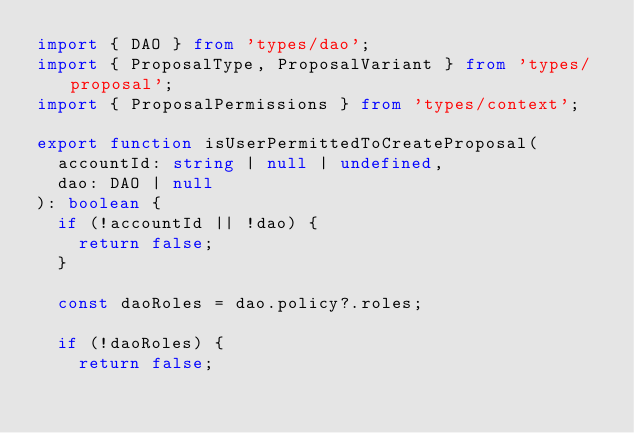Convert code to text. <code><loc_0><loc_0><loc_500><loc_500><_TypeScript_>import { DAO } from 'types/dao';
import { ProposalType, ProposalVariant } from 'types/proposal';
import { ProposalPermissions } from 'types/context';

export function isUserPermittedToCreateProposal(
  accountId: string | null | undefined,
  dao: DAO | null
): boolean {
  if (!accountId || !dao) {
    return false;
  }

  const daoRoles = dao.policy?.roles;

  if (!daoRoles) {
    return false;</code> 